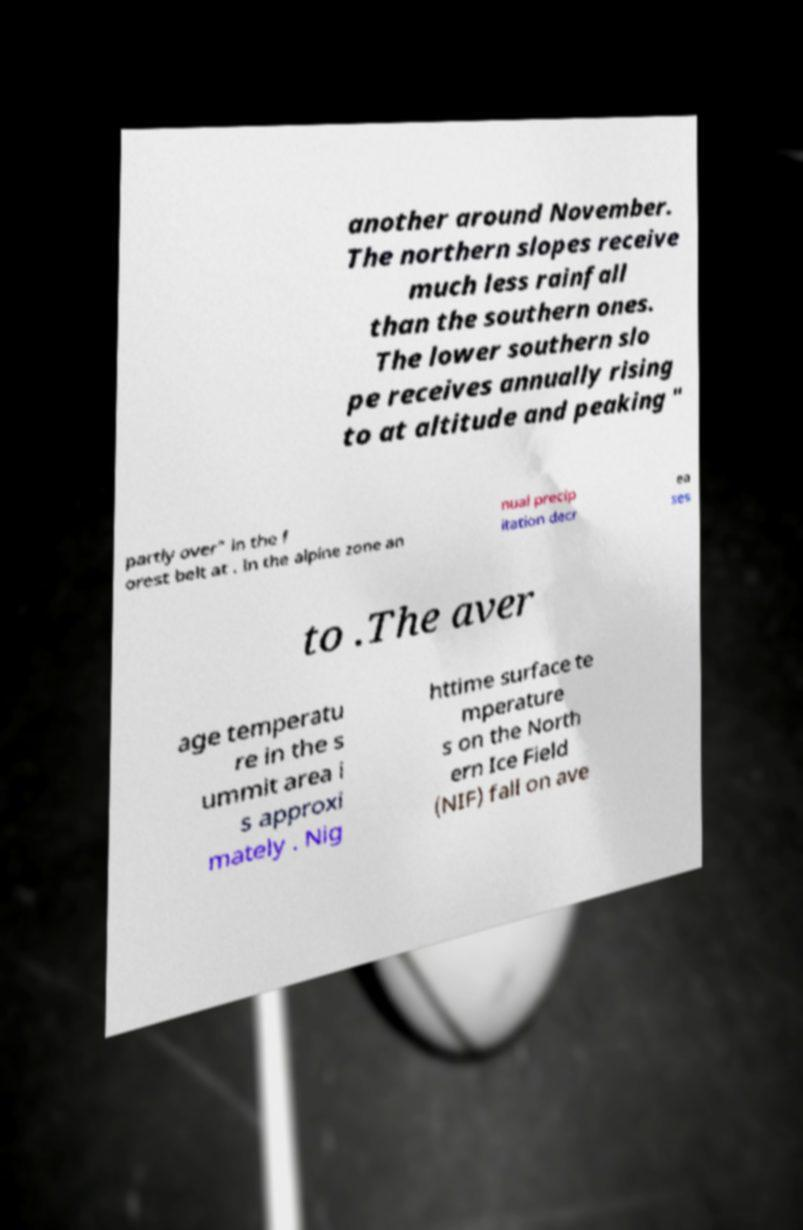Please identify and transcribe the text found in this image. another around November. The northern slopes receive much less rainfall than the southern ones. The lower southern slo pe receives annually rising to at altitude and peaking " partly over" in the f orest belt at . In the alpine zone an nual precip itation decr ea ses to .The aver age temperatu re in the s ummit area i s approxi mately . Nig httime surface te mperature s on the North ern Ice Field (NIF) fall on ave 